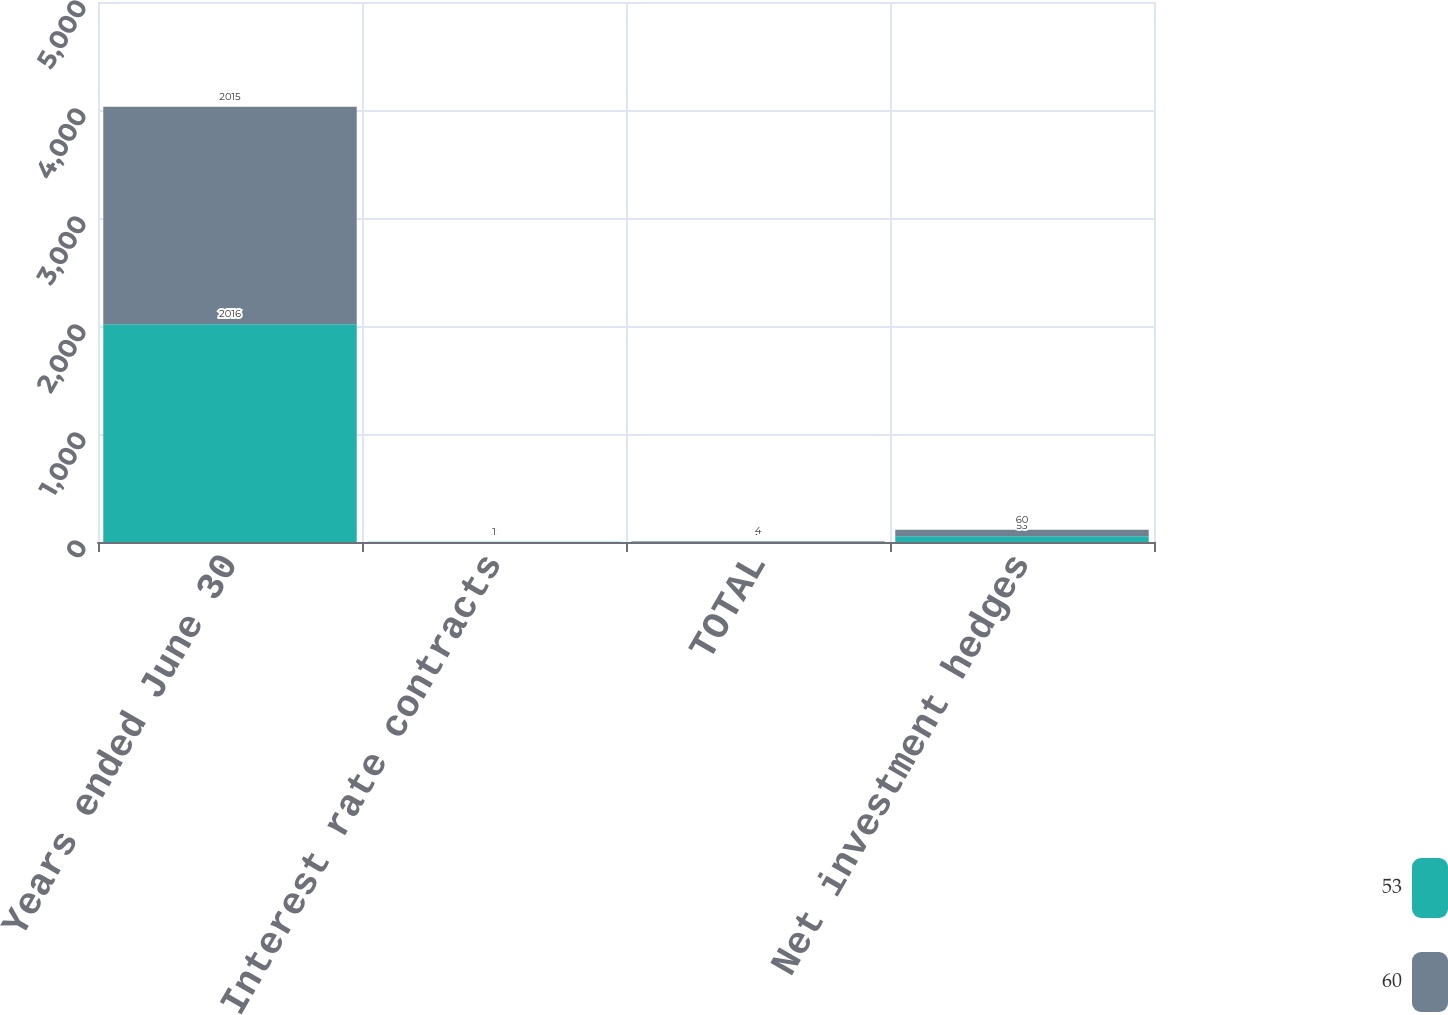Convert chart to OTSL. <chart><loc_0><loc_0><loc_500><loc_500><stacked_bar_chart><ecel><fcel>Years ended June 30<fcel>Interest rate contracts<fcel>TOTAL<fcel>Net investment hedges<nl><fcel>53<fcel>2016<fcel>2<fcel>2<fcel>53<nl><fcel>60<fcel>2015<fcel>1<fcel>4<fcel>60<nl></chart> 